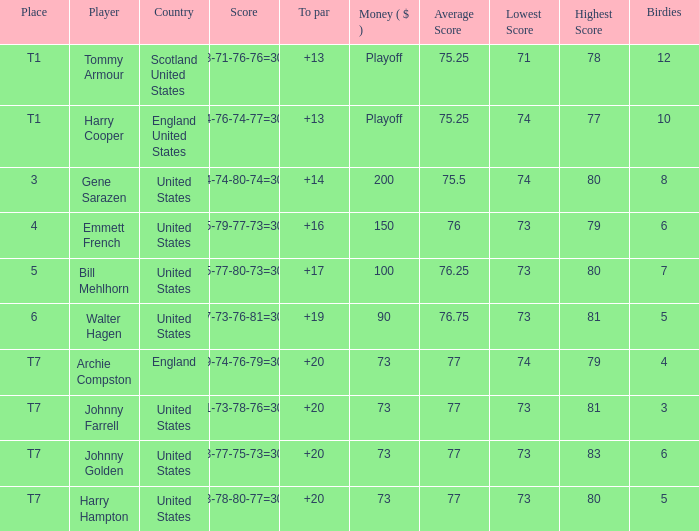Which country has a to par less than 19 and a score of 75-79-77-73=304? United States. 